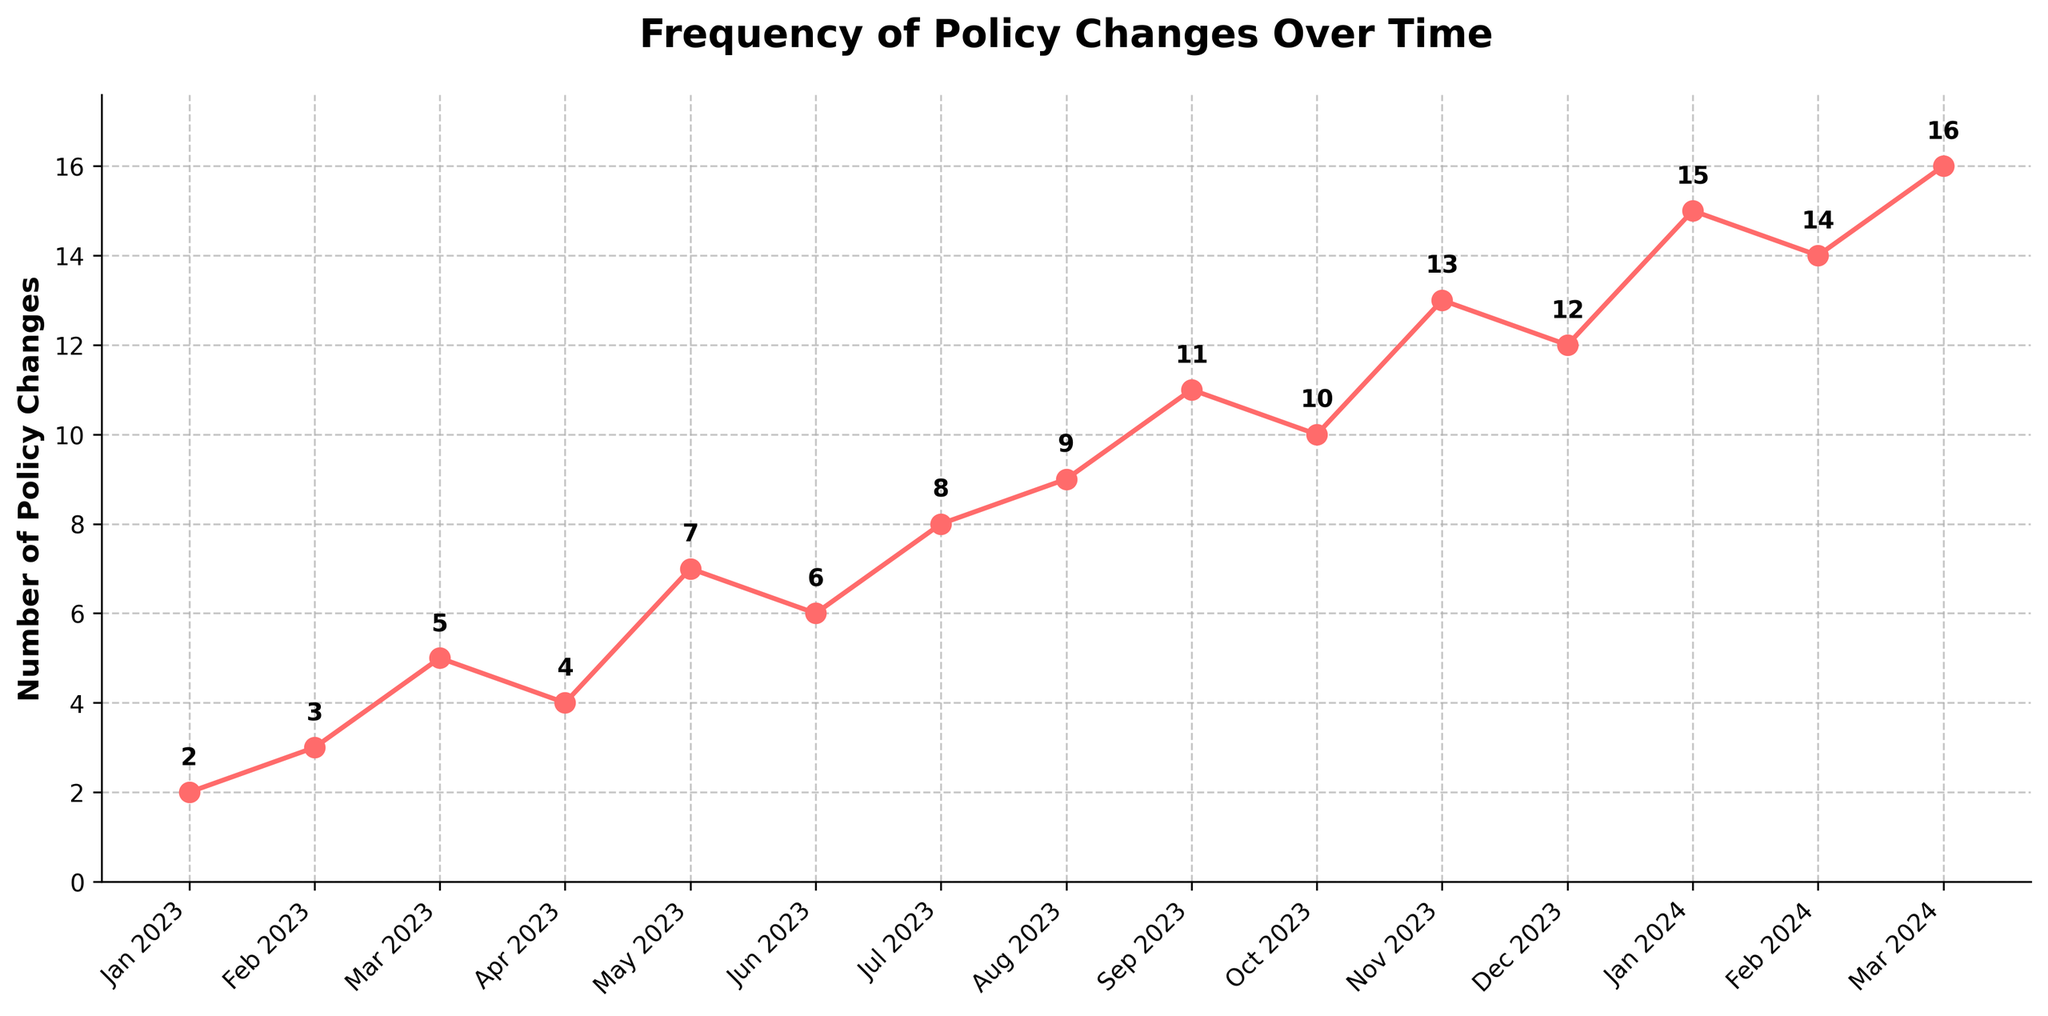What month saw the lowest number of policy changes? The lowest point on the line graph corresponds to January 2023.
Answer: January 2023 Did the number of policy changes ever decrease between consecutive months? By examining the slope of the curve, we can see a decrease from March to April 2023, June to July 2023, October to November 2023, and January to February 2024.
Answer: Yes What is the median number of policy changes from Jan 2023 to Mar 2024? First, order the values: 2, 3, 4, 5, 6, 7, 8, 9, 10, 11, 12, 13, 14, 15, 16. With 15 data points, the median is the 8th value. The 8th value is 9.
Answer: 9 How many more policy changes were made in December 2023 compared to February 2023? December 2023 saw 12 changes, whereas February 2023 saw 3 changes. Therefore, 12 - 3 = 9.
Answer: 9 What is the total number of policy changes for the entire period shown? Sum all the values: 2 + 3 + 5 + 4 + 7 + 6 + 8 + 9 + 11 + 10 + 13 + 12 + 15 + 14 + 16. The total is 135.
Answer: 135 In which month was there the most rapid increase in the number of policy changes? The most rapid increase in terms of the difference from the previous month was from November 2023 to December 2023 with an increase of 13 - 10 = 3.
Answer: November 2023 to December 2023 When did the number of policy changes first reach double digits? By visually checking when the number goes to 10 or more, it first happens in October 2023.
Answer: October 2023 Is the frequency of policy changes more stable in 2023 or 2024? By comparing the fluctuations and variance, 2023 displays smoother and gradual changes, whereas 2024 shows larger jumps.
Answer: 2023 